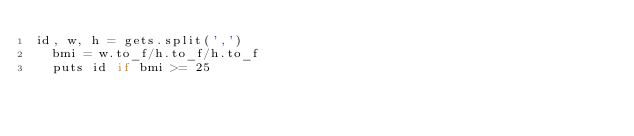Convert code to text. <code><loc_0><loc_0><loc_500><loc_500><_Ruby_>id, w, h = gets.split(',')
  bmi = w.to_f/h.to_f/h.to_f
  puts id if bmi >= 25</code> 